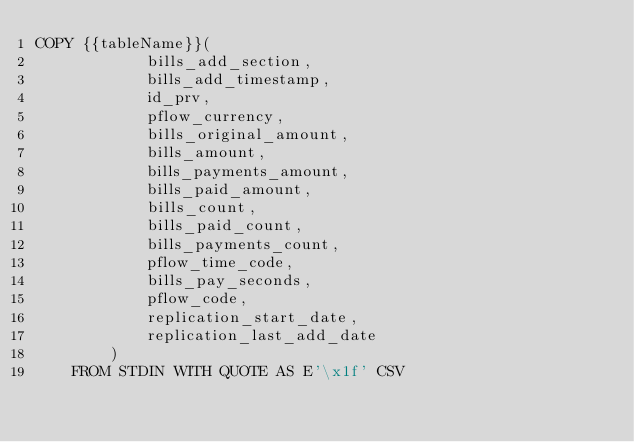<code> <loc_0><loc_0><loc_500><loc_500><_SQL_>COPY {{tableName}}(
			bills_add_section,
			bills_add_timestamp,
			id_prv,
			pflow_currency,
			bills_original_amount,
			bills_amount,
			bills_payments_amount,
			bills_paid_amount,
			bills_count,
			bills_paid_count,
			bills_payments_count,
			pflow_time_code,
			bills_pay_seconds,
			pflow_code,
			replication_start_date,
			replication_last_add_date
		)
	FROM STDIN WITH QUOTE AS E'\x1f' CSV

</code> 